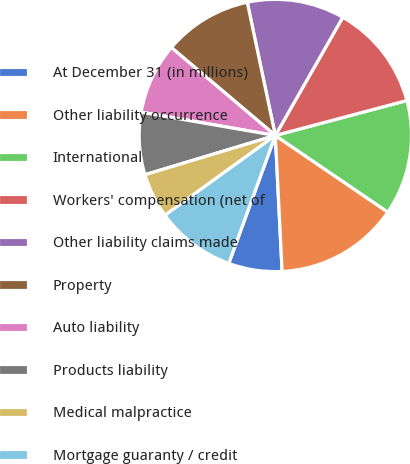Convert chart. <chart><loc_0><loc_0><loc_500><loc_500><pie_chart><fcel>At December 31 (in millions)<fcel>Other liability occurrence<fcel>International<fcel>Workers' compensation (net of<fcel>Other liability claims made<fcel>Property<fcel>Auto liability<fcel>Products liability<fcel>Medical malpractice<fcel>Mortgage guaranty / credit<nl><fcel>6.35%<fcel>14.69%<fcel>13.65%<fcel>12.61%<fcel>11.56%<fcel>10.52%<fcel>8.44%<fcel>7.39%<fcel>5.31%<fcel>9.48%<nl></chart> 